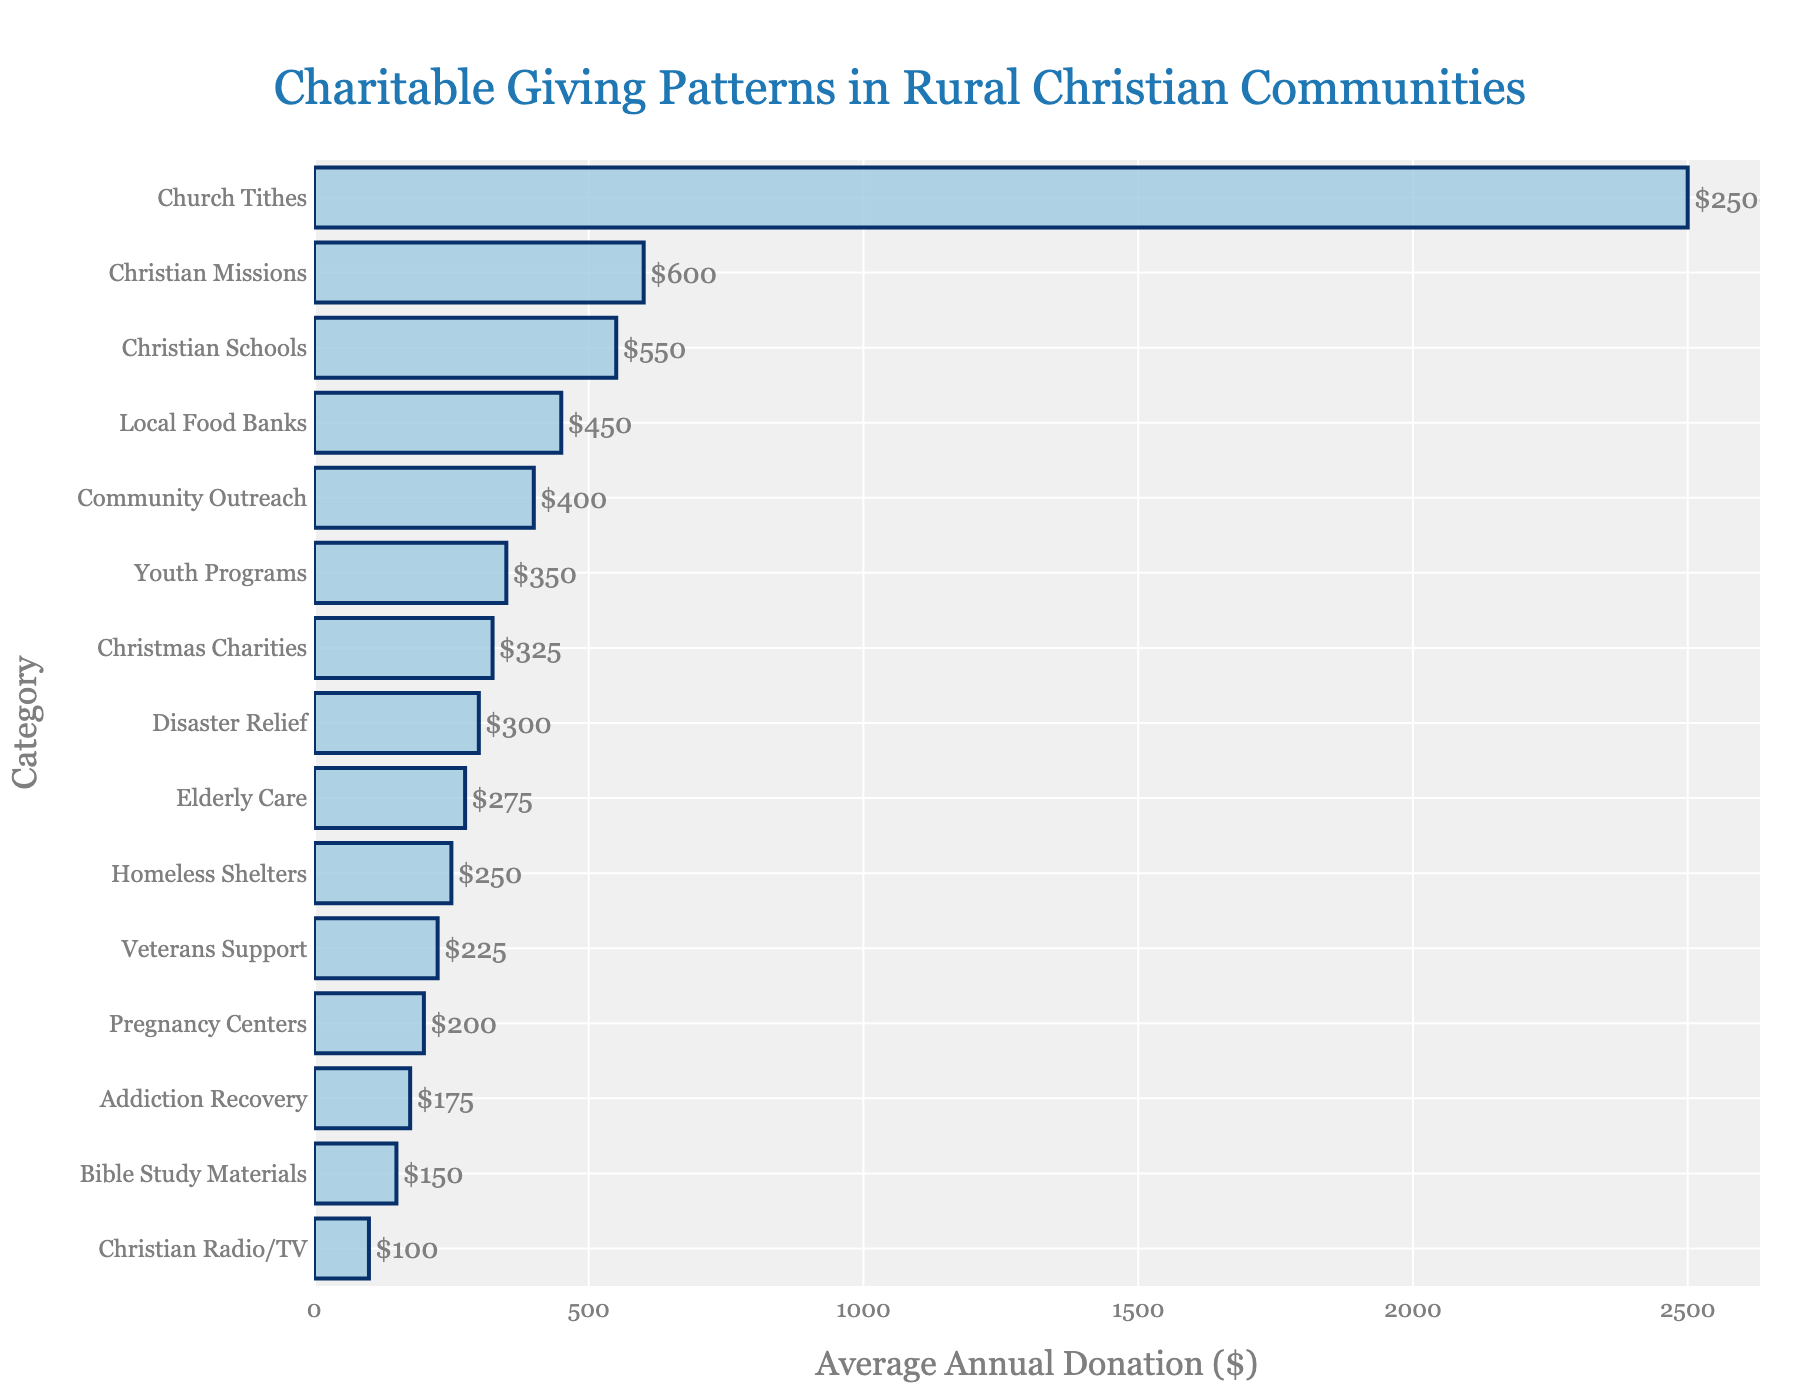Which category receives the highest average annual donation? The category with the highest average annual donation is the one represented by the longest bar in the figure. Referring to the chart, the longest bar corresponds to "Church Tithes" with $2500.
Answer: Church Tithes Which category receives the lowest average annual donation? The category with the lowest average annual donation is indicated by the shortest bar in the chart. According to the figure, the shortest bar corresponds to "Christian Radio/TV" with $100.
Answer: Christian Radio/TV How much more is donated on average to Christian Missions compared to Homeless Shelters? Identify the bars for Christian Missions and Homeless Shelters and note their average donations, which are $600 and $250 respectively. The difference is $600 - $250 = $350.
Answer: $350 What is the total average annual donation to Christian schools, elderly care, and veterans support? Sum the average donations for Christian Schools ($550), Elderly Care ($275), and Veterans Support ($225). The total is $550 + $275 + $225 = $1050.
Answer: $1050 Are donations to Youth Programs higher, lower, or the same as donations to Disaster Relief? Compare the bar lengths for Youth Programs and Disaster Relief. Youth Programs receive an average donation of $350, while Disaster Relief receives $300. Therefore, Youth Programs receive higher donations.
Answer: Higher What’s the difference between the highest and the lowest average annual donation amounts? The highest donation amount is for Church Tithes ($2500) and the lowest is for Christian Radio/TV ($100). The difference is $2500 - $100 = $2400.
Answer: $2400 What is the sum of average donations to categories that focus on broader community services (Community Outreach, Local Food Banks, Homeless Shelters)? The average donations for Community Outreach, Local Food Banks, and Homeless Shelters are $400, $450, and $250 respectively. The sum is $400 + $450 + $250 = $1100.
Answer: $1100 Which two categories have the closest average annual donations, and what are the amounts? Inspect the bars to find two categories with nearly equal lengths. Christian Missions ($600) and Christian Schools ($550) have close average donations; the difference is $50.
Answer: Christian Missions and Christian Schools What is the average donation for the three categories with the lowest values? The lowest three donations are to Christian Radio/TV ($100), Bible Study Materials ($150), and Addiction Recovery ($175). Their total is $100 + $150 + $175 = $425, and the average is $425 / 3 = $141.67.
Answer: $141.67 